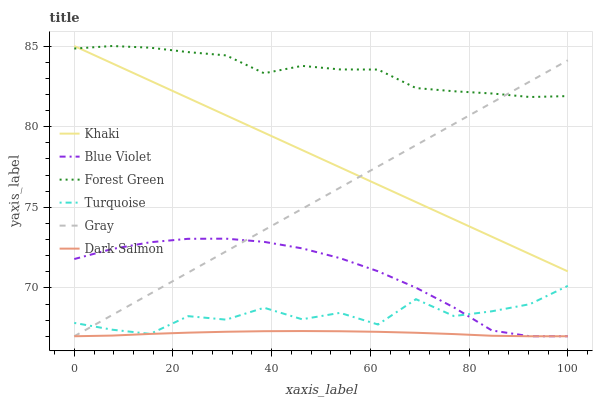Does Dark Salmon have the minimum area under the curve?
Answer yes or no. Yes. Does Forest Green have the maximum area under the curve?
Answer yes or no. Yes. Does Turquoise have the minimum area under the curve?
Answer yes or no. No. Does Turquoise have the maximum area under the curve?
Answer yes or no. No. Is Khaki the smoothest?
Answer yes or no. Yes. Is Turquoise the roughest?
Answer yes or no. Yes. Is Turquoise the smoothest?
Answer yes or no. No. Is Khaki the roughest?
Answer yes or no. No. Does Gray have the lowest value?
Answer yes or no. Yes. Does Turquoise have the lowest value?
Answer yes or no. No. Does Forest Green have the highest value?
Answer yes or no. Yes. Does Turquoise have the highest value?
Answer yes or no. No. Is Turquoise less than Forest Green?
Answer yes or no. Yes. Is Khaki greater than Turquoise?
Answer yes or no. Yes. Does Gray intersect Dark Salmon?
Answer yes or no. Yes. Is Gray less than Dark Salmon?
Answer yes or no. No. Is Gray greater than Dark Salmon?
Answer yes or no. No. Does Turquoise intersect Forest Green?
Answer yes or no. No. 